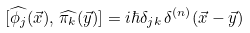Convert formula to latex. <formula><loc_0><loc_0><loc_500><loc_500>[ \widehat { \phi _ { j } } ( \vec { x } ) , \, \widehat { \pi _ { k } } ( \vec { y } ) ] = i \hbar { \delta } _ { j k } \, \delta ^ { ( n ) } ( \vec { x } - \vec { y } )</formula> 